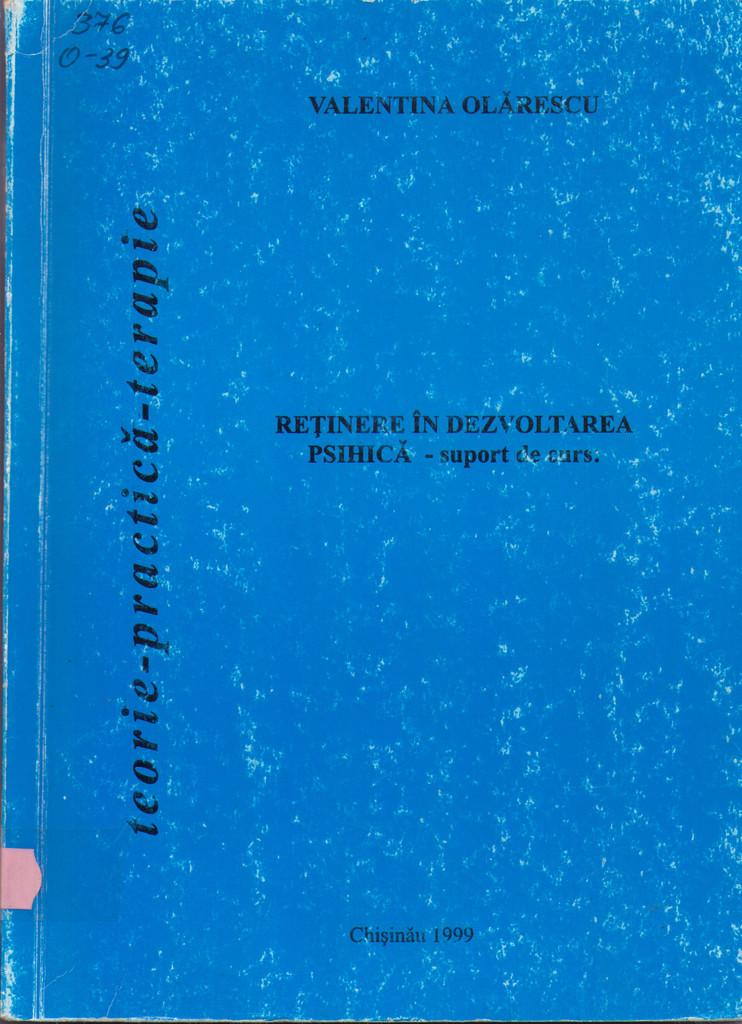Who wrote this book?
Your response must be concise. Valentina olarescu. What year is listed on the book?
Your answer should be very brief. 1999. 